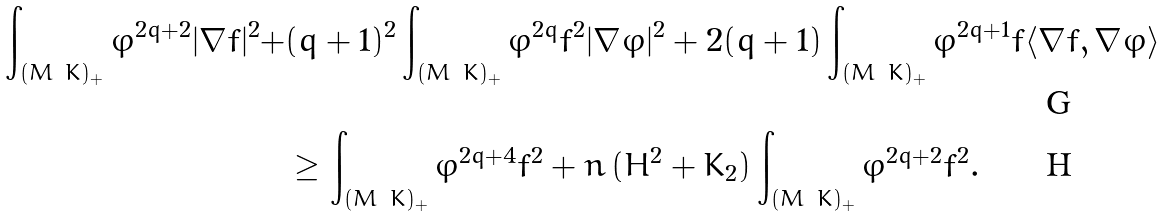<formula> <loc_0><loc_0><loc_500><loc_500>\int _ { ( M \ K ) _ { + } } \varphi ^ { 2 q + 2 } | \nabla f | ^ { 2 } + & ( q + 1 ) ^ { 2 } \int _ { ( M \ K ) _ { + } } \varphi ^ { 2 q } f ^ { 2 } | \nabla \varphi | ^ { 2 } + 2 ( q + 1 ) \int _ { ( M \ K ) _ { + } } \varphi ^ { 2 q + 1 } f \langle \nabla f , \nabla \varphi \rangle \\ & \geq \int _ { ( M \ K ) _ { + } } \varphi ^ { 2 q + 4 } f ^ { 2 } + n \, ( H ^ { 2 } + K _ { 2 } ) \int _ { ( M \ K ) _ { + } } \varphi ^ { 2 q + 2 } f ^ { 2 } .</formula> 